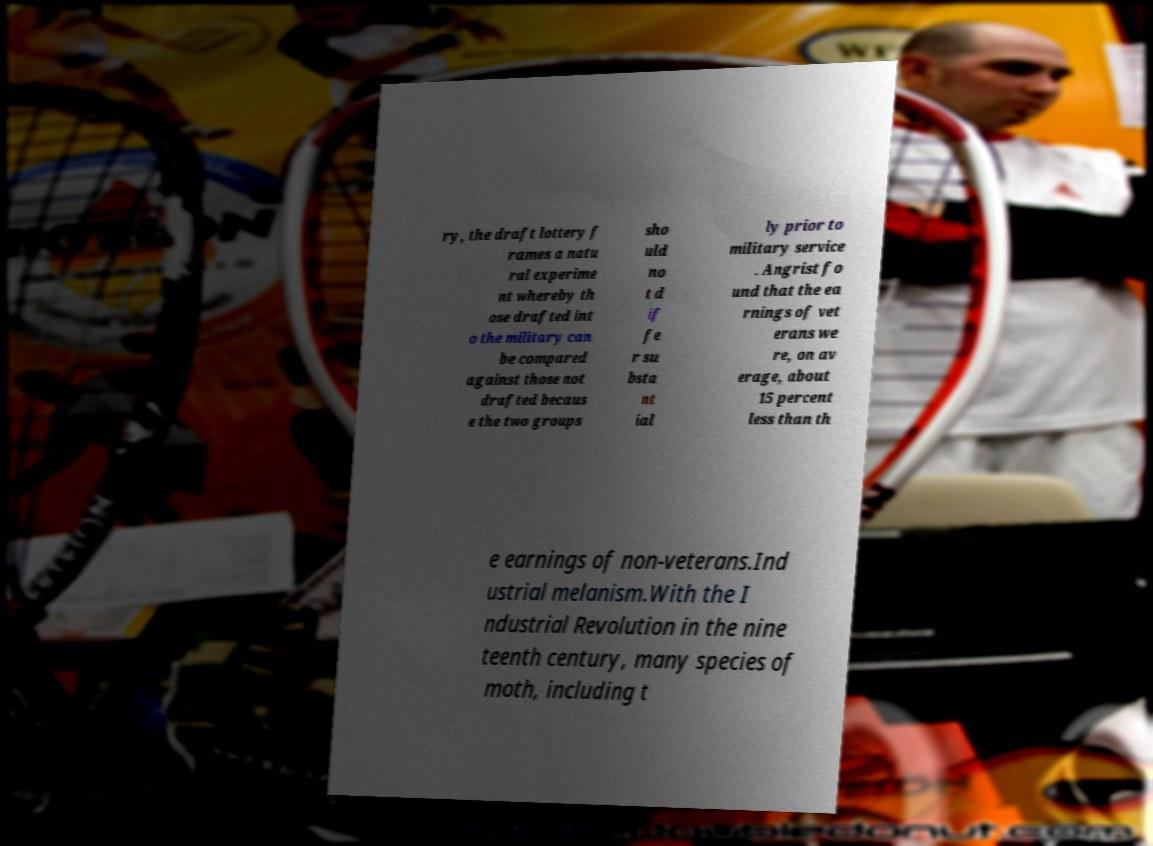I need the written content from this picture converted into text. Can you do that? ry, the draft lottery f rames a natu ral experime nt whereby th ose drafted int o the military can be compared against those not drafted becaus e the two groups sho uld no t d if fe r su bsta nt ial ly prior to military service . Angrist fo und that the ea rnings of vet erans we re, on av erage, about 15 percent less than th e earnings of non-veterans.Ind ustrial melanism.With the I ndustrial Revolution in the nine teenth century, many species of moth, including t 